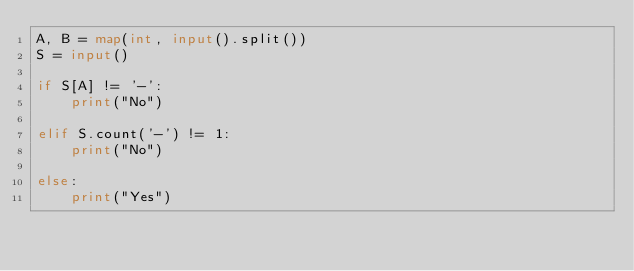Convert code to text. <code><loc_0><loc_0><loc_500><loc_500><_Python_>A, B = map(int, input().split())
S = input()

if S[A] != '-':
    print("No")

elif S.count('-') != 1:
    print("No")

else:
    print("Yes")</code> 